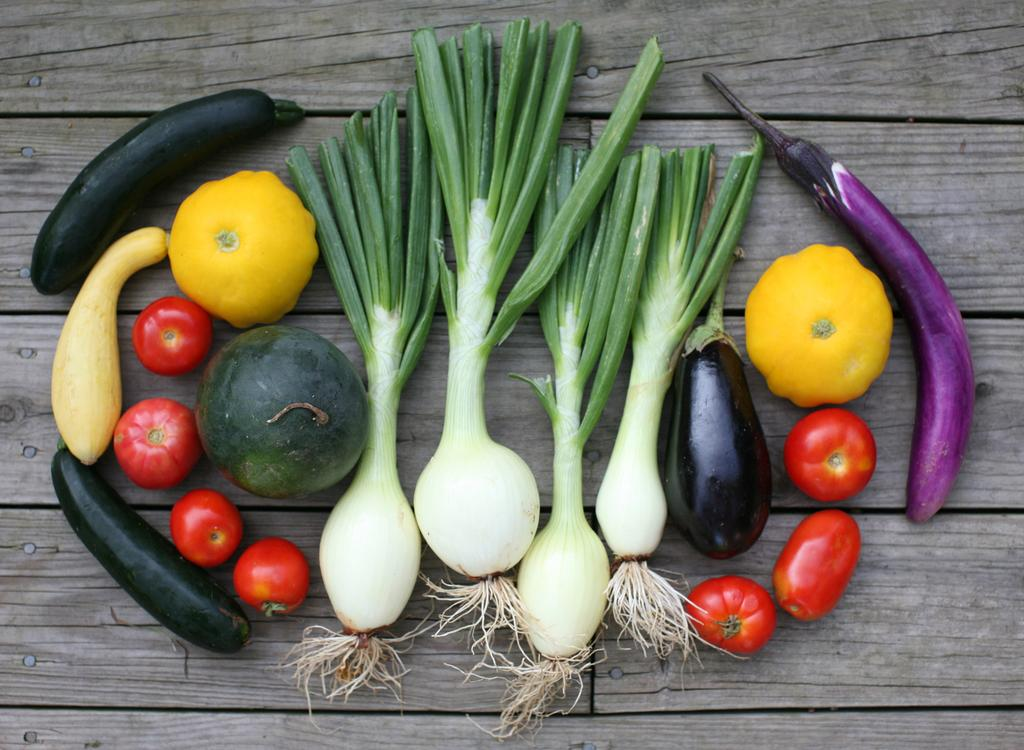What type of food can be seen in the image? There are vegetables in the image. What is the surface made of that the vegetables are on? The vegetables are on a wooden surface. Can you see a stream flowing through the vegetables in the image? No, there is no stream present in the image. 